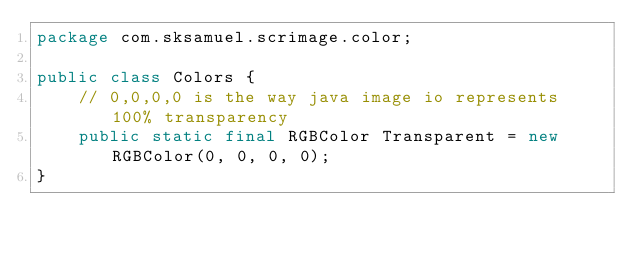Convert code to text. <code><loc_0><loc_0><loc_500><loc_500><_Java_>package com.sksamuel.scrimage.color;

public class Colors {
    // 0,0,0,0 is the way java image io represents 100% transparency
    public static final RGBColor Transparent = new RGBColor(0, 0, 0, 0);
}
</code> 